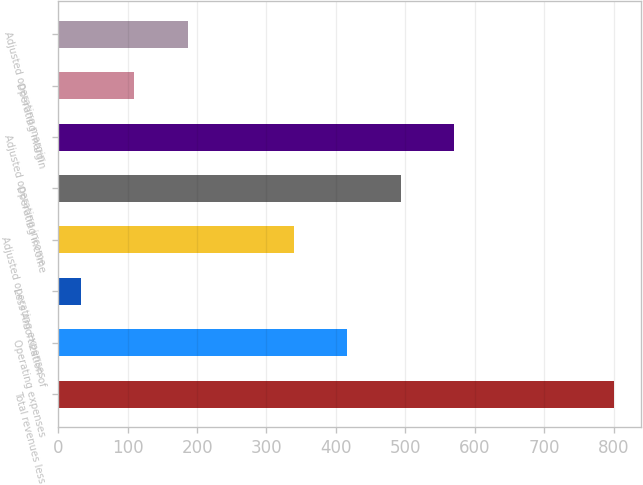Convert chart. <chart><loc_0><loc_0><loc_500><loc_500><bar_chart><fcel>Total revenues less<fcel>Operating expenses<fcel>Less Amortization of<fcel>Adjusted operating expenses<fcel>Operating income<fcel>Adjusted operating income<fcel>Operating margin<fcel>Adjusted operating margin<nl><fcel>800<fcel>416.7<fcel>33<fcel>340<fcel>493.4<fcel>570.1<fcel>109.7<fcel>186.4<nl></chart> 